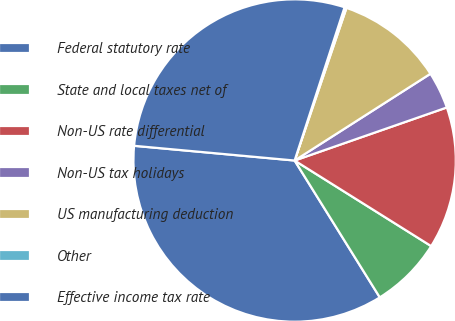<chart> <loc_0><loc_0><loc_500><loc_500><pie_chart><fcel>Federal statutory rate<fcel>State and local taxes net of<fcel>Non-US rate differential<fcel>Non-US tax holidays<fcel>US manufacturing deduction<fcel>Other<fcel>Effective income tax rate<nl><fcel>35.32%<fcel>7.23%<fcel>14.25%<fcel>3.71%<fcel>10.74%<fcel>0.2%<fcel>28.56%<nl></chart> 